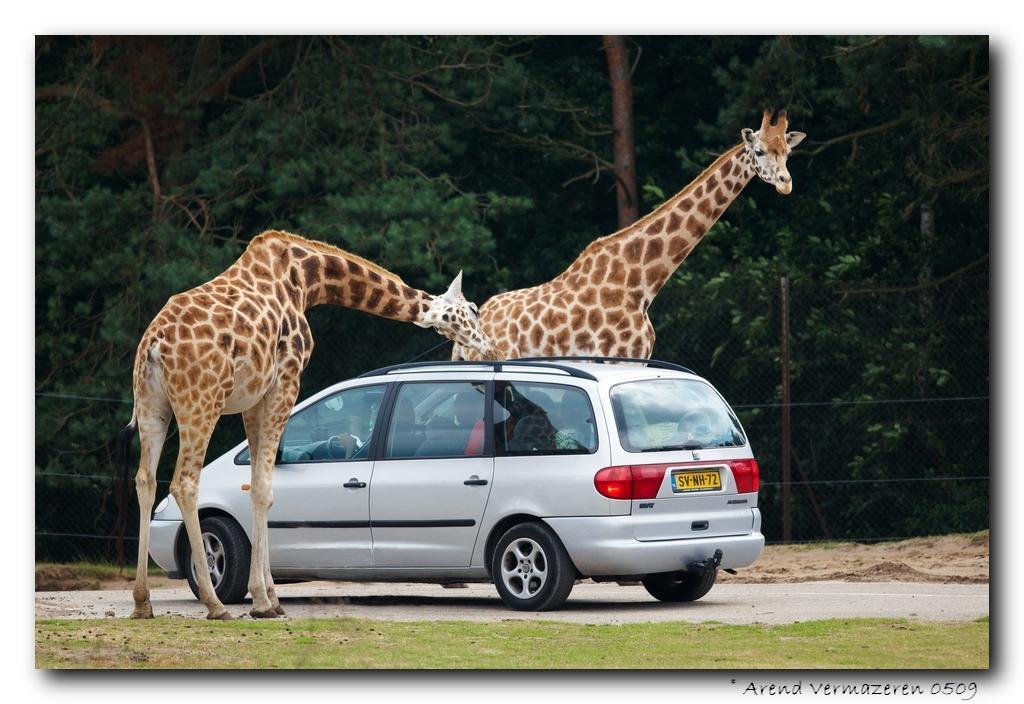Could you give a brief overview of what you see in this image? In this picture there are giraffes standing and there is a vehicle on the road and there are people inside the vehicle. At the back there are trees and there is a fence. At the bottom there is a road and there's grass on the ground. At the bottom right there is text. 